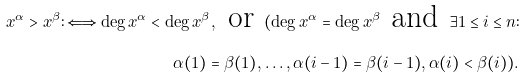<formula> <loc_0><loc_0><loc_500><loc_500>x ^ { \alpha } > x ^ { \beta } \colon \Longleftrightarrow \deg x ^ { \alpha } < \deg x ^ { \beta } , \text { or } ( \deg x ^ { \alpha } = \deg x ^ { \beta } \text { and } \exists 1 \leq i \leq n \colon \\ \alpha ( 1 ) = \beta ( 1 ) , \dots , \alpha ( i - 1 ) = \beta ( i - 1 ) , \alpha ( i ) < \beta ( i ) ) .</formula> 